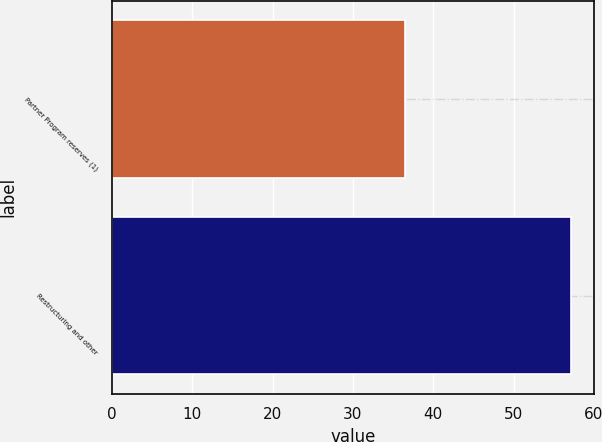Convert chart. <chart><loc_0><loc_0><loc_500><loc_500><bar_chart><fcel>Partner Program reserves (1)<fcel>Restructuring and other<nl><fcel>36.5<fcel>57.2<nl></chart> 